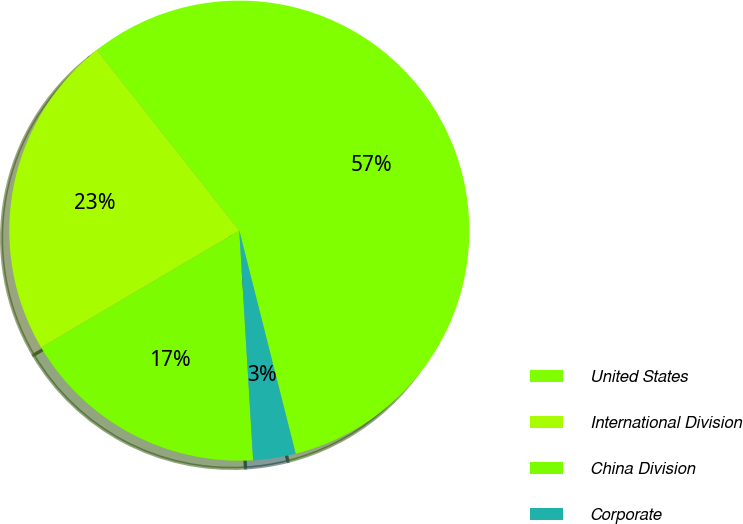Convert chart to OTSL. <chart><loc_0><loc_0><loc_500><loc_500><pie_chart><fcel>United States<fcel>International Division<fcel>China Division<fcel>Corporate<nl><fcel>56.69%<fcel>22.85%<fcel>17.48%<fcel>2.98%<nl></chart> 